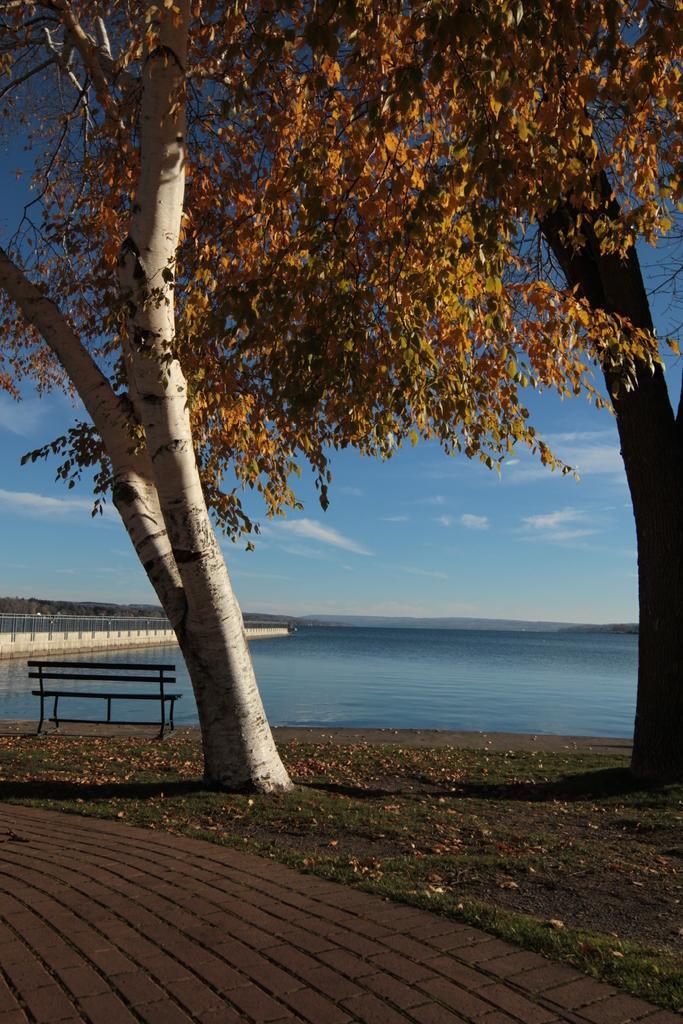Can you describe this image briefly? In this picture we can see a bench, leaves and trees on the ground and in the background we can see water, sky with clouds. 